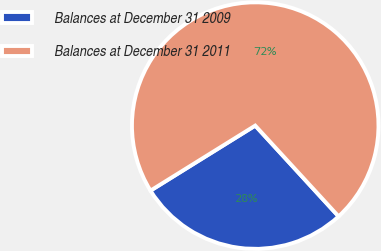Convert chart to OTSL. <chart><loc_0><loc_0><loc_500><loc_500><pie_chart><fcel>Balances at December 31 2009<fcel>Balances at December 31 2011<nl><fcel>27.98%<fcel>72.02%<nl></chart> 